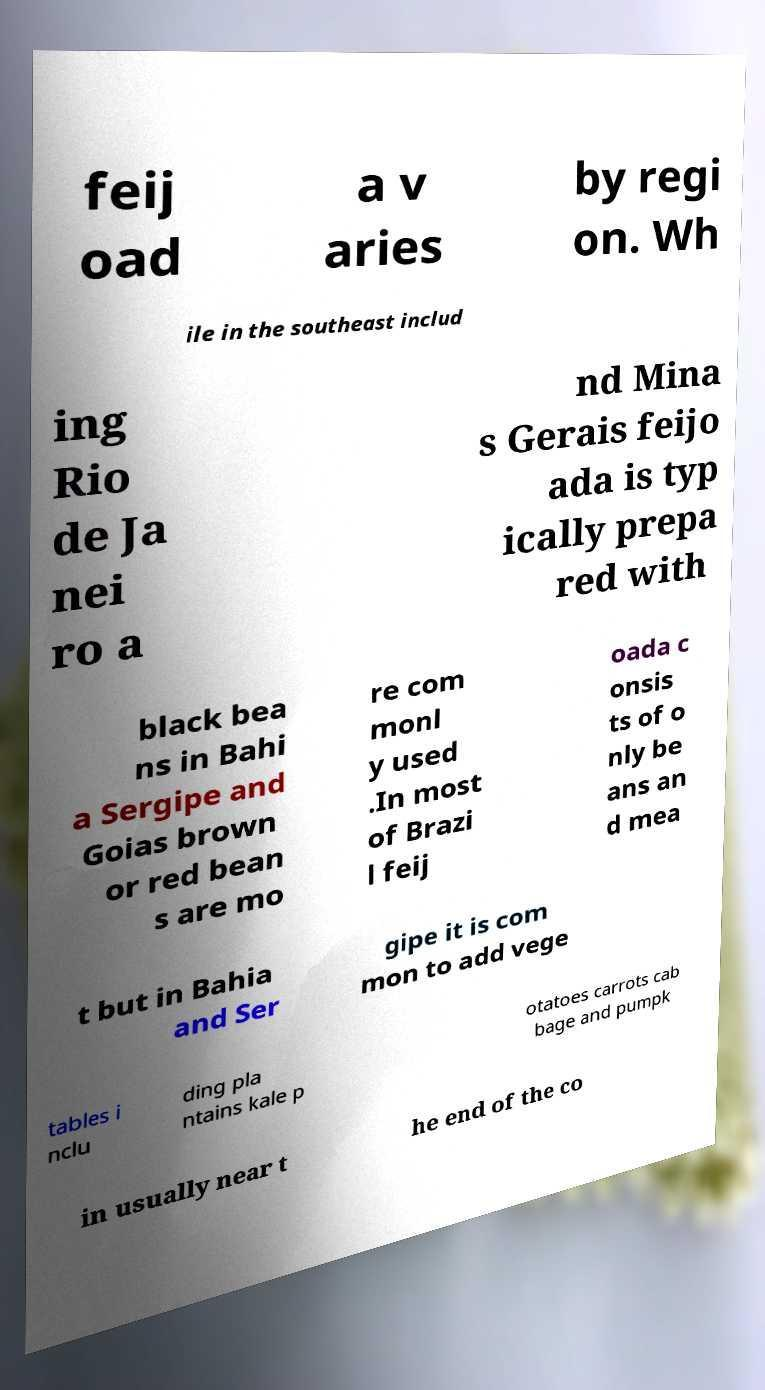What messages or text are displayed in this image? I need them in a readable, typed format. feij oad a v aries by regi on. Wh ile in the southeast includ ing Rio de Ja nei ro a nd Mina s Gerais feijo ada is typ ically prepa red with black bea ns in Bahi a Sergipe and Goias brown or red bean s are mo re com monl y used .In most of Brazi l feij oada c onsis ts of o nly be ans an d mea t but in Bahia and Ser gipe it is com mon to add vege tables i nclu ding pla ntains kale p otatoes carrots cab bage and pumpk in usually near t he end of the co 